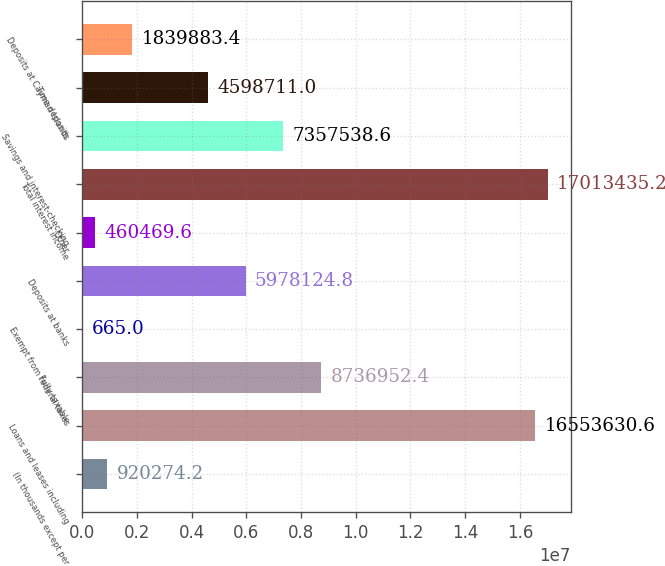Convert chart. <chart><loc_0><loc_0><loc_500><loc_500><bar_chart><fcel>(In thousands except per<fcel>Loans and leases including<fcel>Fully taxable<fcel>Exempt from federal taxes<fcel>Deposits at banks<fcel>Other<fcel>Total interest income<fcel>Savings and interest-checking<fcel>Time deposits<fcel>Deposits at Cayman Islands<nl><fcel>920274<fcel>1.65536e+07<fcel>8.73695e+06<fcel>665<fcel>5.97812e+06<fcel>460470<fcel>1.70134e+07<fcel>7.35754e+06<fcel>4.59871e+06<fcel>1.83988e+06<nl></chart> 